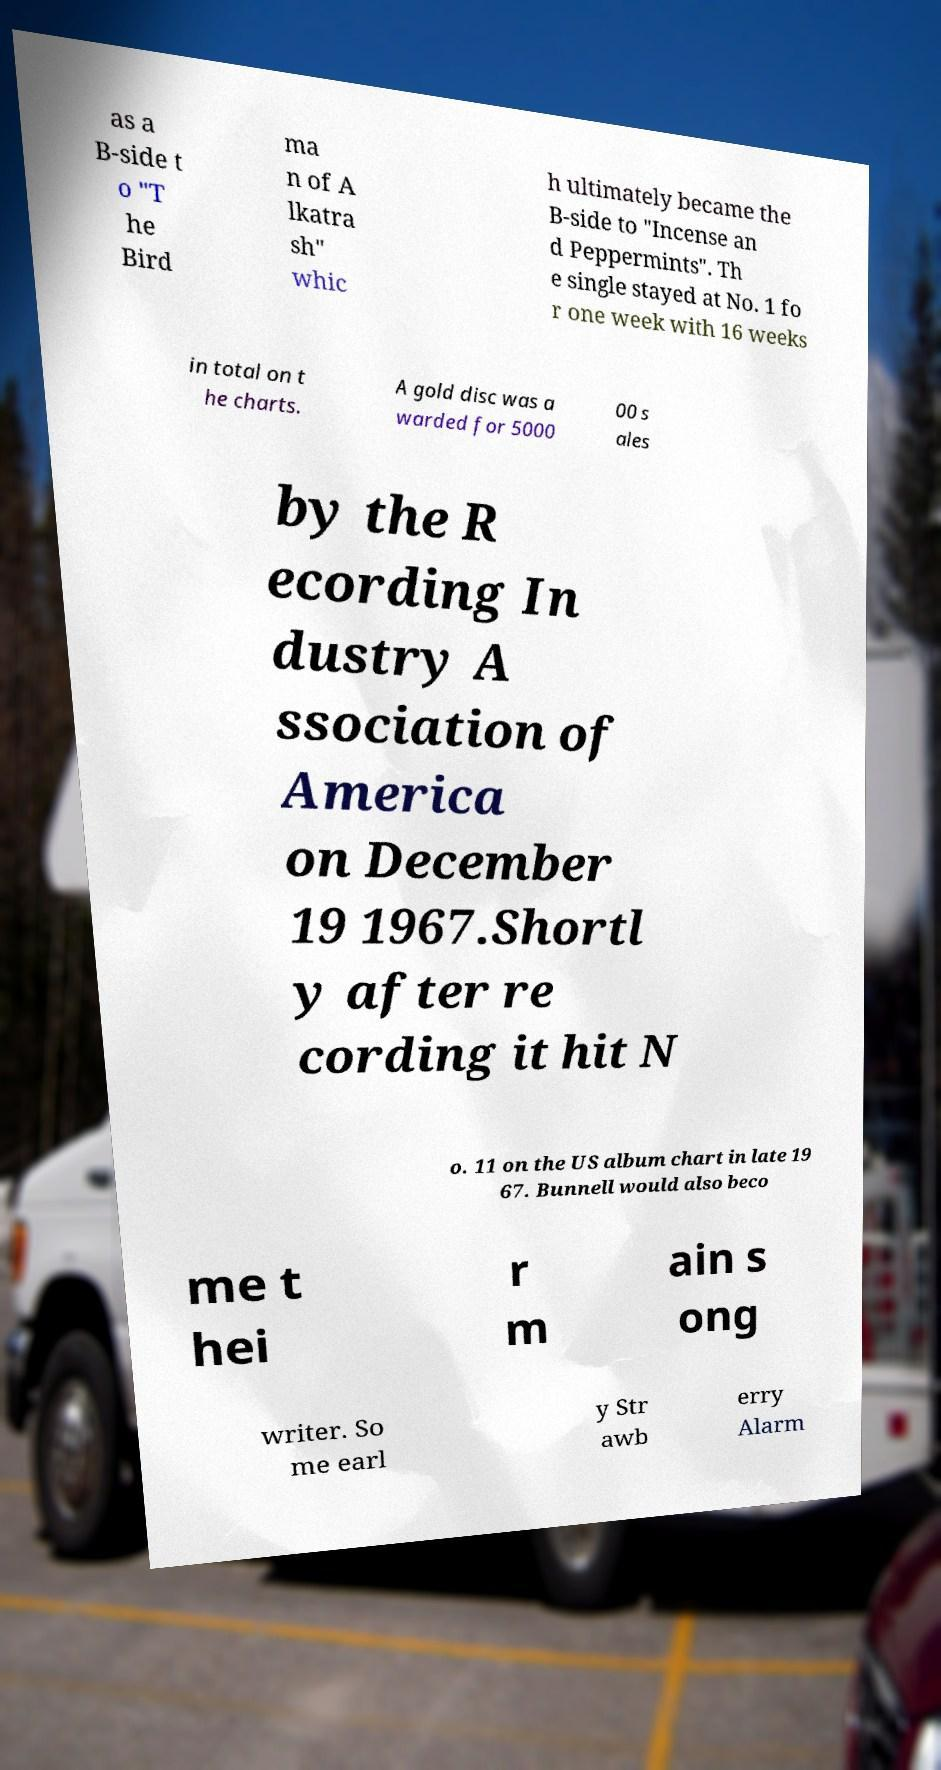Could you extract and type out the text from this image? as a B-side t o "T he Bird ma n of A lkatra sh" whic h ultimately became the B-side to "Incense an d Peppermints". Th e single stayed at No. 1 fo r one week with 16 weeks in total on t he charts. A gold disc was a warded for 5000 00 s ales by the R ecording In dustry A ssociation of America on December 19 1967.Shortl y after re cording it hit N o. 11 on the US album chart in late 19 67. Bunnell would also beco me t hei r m ain s ong writer. So me earl y Str awb erry Alarm 